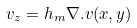Convert formula to latex. <formula><loc_0><loc_0><loc_500><loc_500>v _ { z } = h _ { m } \nabla . v ( x , y )</formula> 